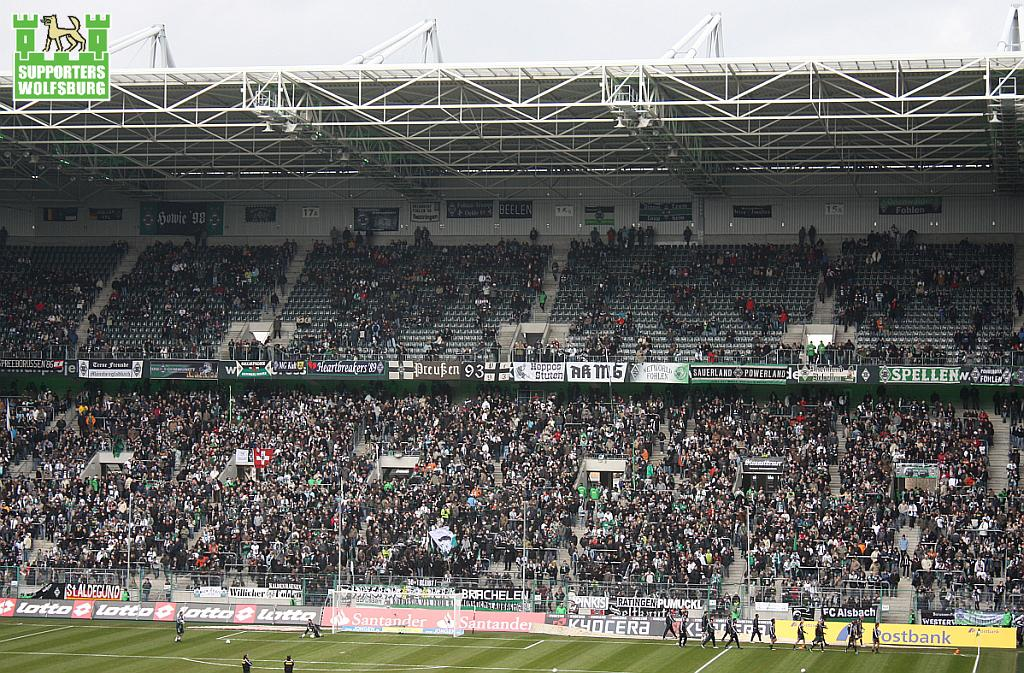What type of surface is visible in the image? There is ground visible in the image. What are the persons in the image doing? There are persons standing on the ground. What objects can be seen in the image besides the ground? There are boards present in the image. What type of animals can be seen in the image? There are moles visible in the image. Where are the persons located in the image? The persons are in a stadium. What is visible in the background of the image? The sky is visible in the background of the image. What type of face can be seen on the boat in the image? There is no boat present in the image, so there is no face to be seen on a boat. 